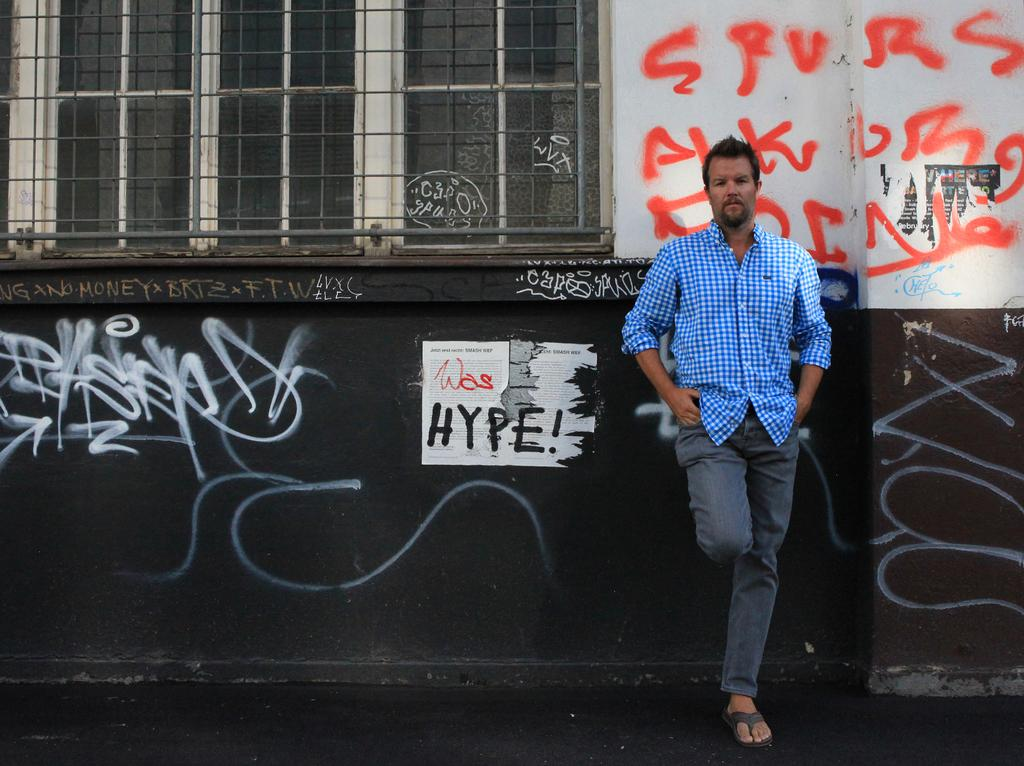Who is the main subject in the image? There is a man in the image. What is the man doing in the image? The man is posing for a camera. What can be seen in the background of the image? There is a wall, posters, and a window in the background of the image. What type of juice is being squeezed by the man's toe in the image? There is no juice or toe present in the image; the man is posing for a camera, and the background features a wall, posters, and a window. 